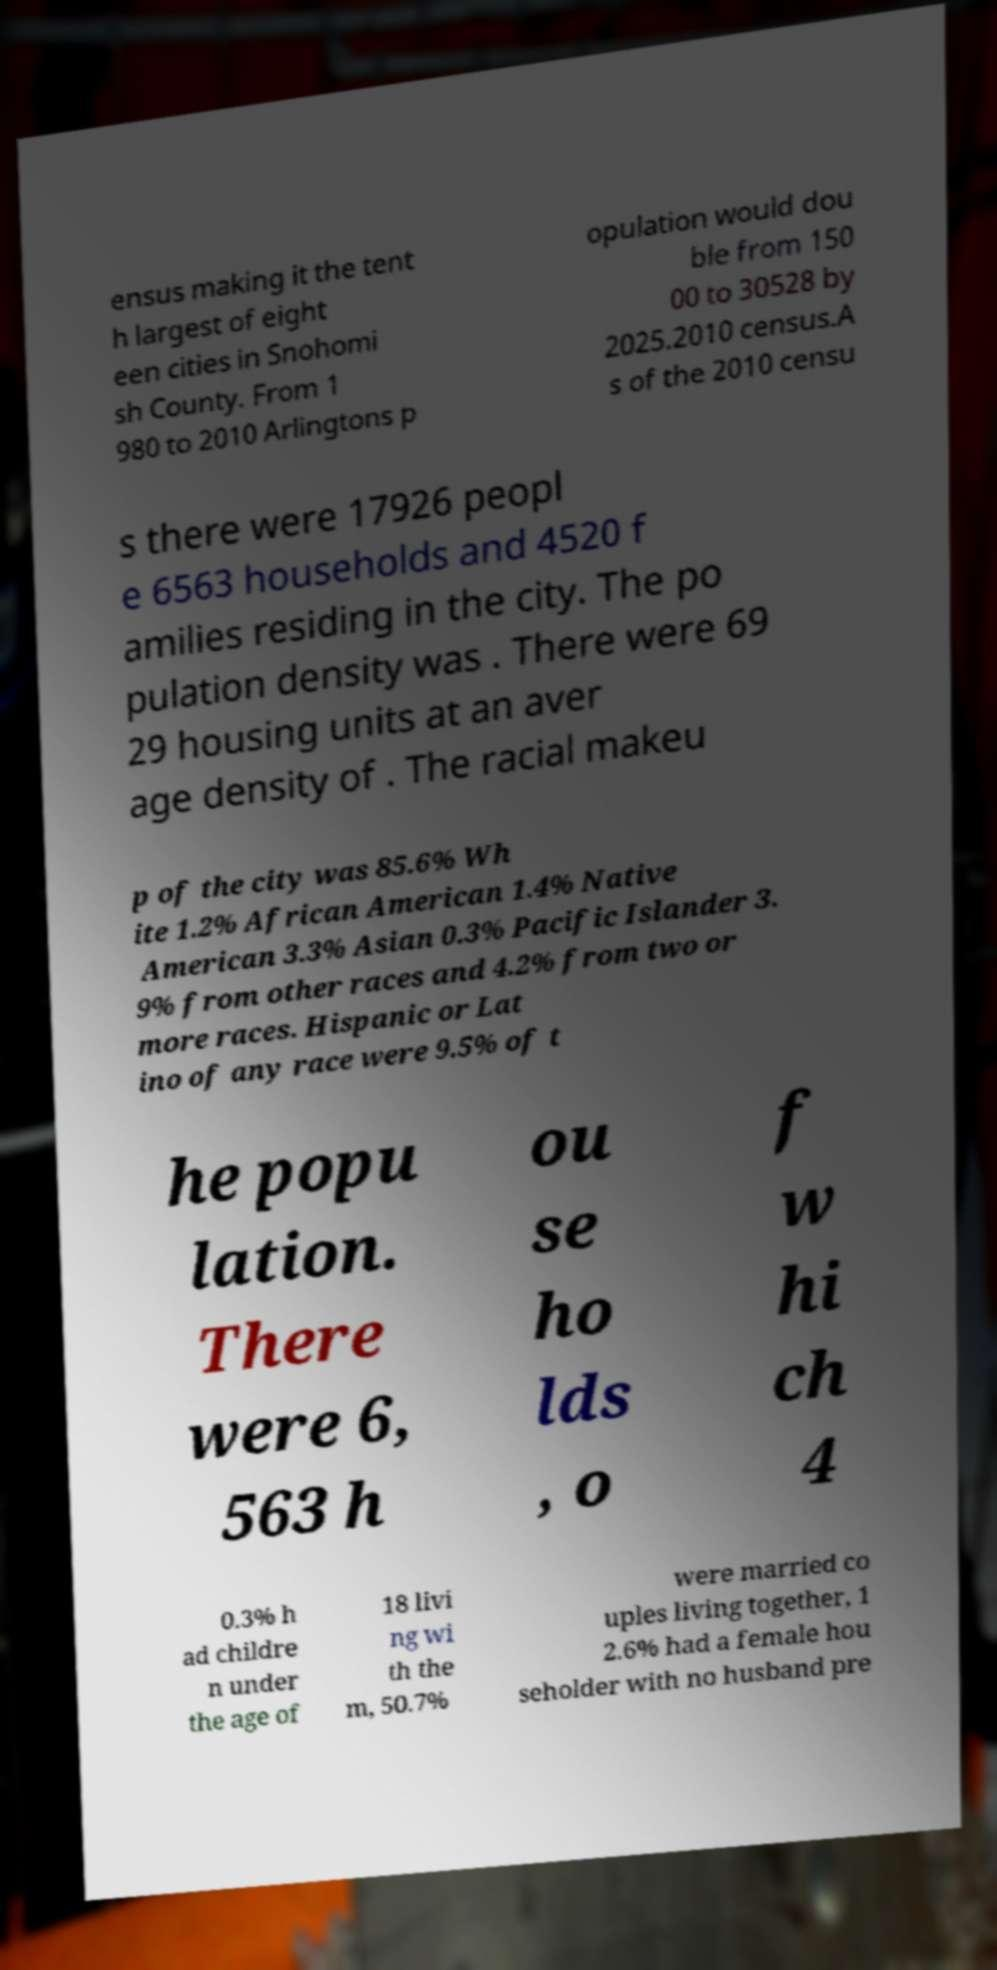Can you accurately transcribe the text from the provided image for me? ensus making it the tent h largest of eight een cities in Snohomi sh County. From 1 980 to 2010 Arlingtons p opulation would dou ble from 150 00 to 30528 by 2025.2010 census.A s of the 2010 censu s there were 17926 peopl e 6563 households and 4520 f amilies residing in the city. The po pulation density was . There were 69 29 housing units at an aver age density of . The racial makeu p of the city was 85.6% Wh ite 1.2% African American 1.4% Native American 3.3% Asian 0.3% Pacific Islander 3. 9% from other races and 4.2% from two or more races. Hispanic or Lat ino of any race were 9.5% of t he popu lation. There were 6, 563 h ou se ho lds , o f w hi ch 4 0.3% h ad childre n under the age of 18 livi ng wi th the m, 50.7% were married co uples living together, 1 2.6% had a female hou seholder with no husband pre 